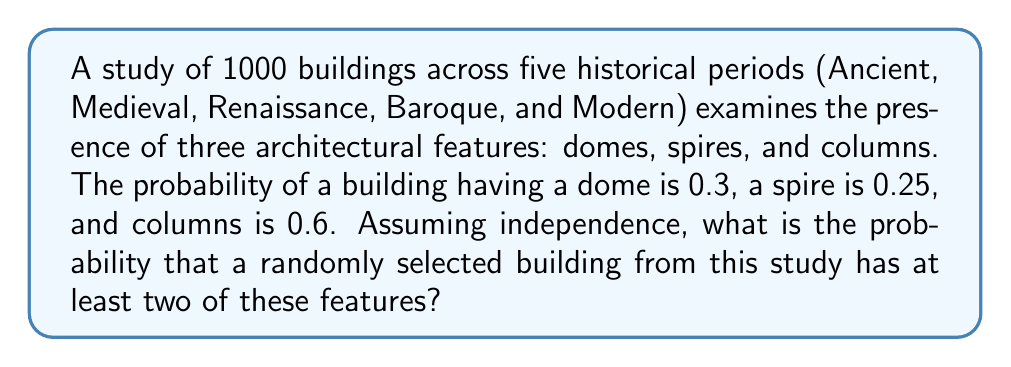Help me with this question. Let's approach this step-by-step:

1) First, we need to calculate the probability of a building having exactly 0, 1, 2, or 3 features.

2) Let's define events:
   D: building has a dome
   S: building has a spire
   C: building has columns

3) Given probabilities:
   $P(D) = 0.3$
   $P(S) = 0.25$
   $P(C) = 0.6$

4) Probability of not having each feature:
   $P(\text{not D}) = 1 - 0.3 = 0.7$
   $P(\text{not S}) = 1 - 0.25 = 0.75$
   $P(\text{not C}) = 1 - 0.6 = 0.4$

5) Probability of having no features:
   $P(0) = 0.7 \times 0.75 \times 0.4 = 0.21$

6) Probability of having exactly one feature:
   $P(1) = (0.3 \times 0.75 \times 0.4) + (0.7 \times 0.25 \times 0.4) + (0.7 \times 0.75 \times 0.6)$
   $= 0.09 + 0.07 + 0.315 = 0.475$

7) Probability of having at least two features:
   $P(\text{at least 2}) = 1 - P(0) - P(1)$
   $= 1 - 0.21 - 0.475 = 0.315$

Therefore, the probability of a randomly selected building having at least two of these features is 0.315 or 31.5%.
Answer: 0.315 